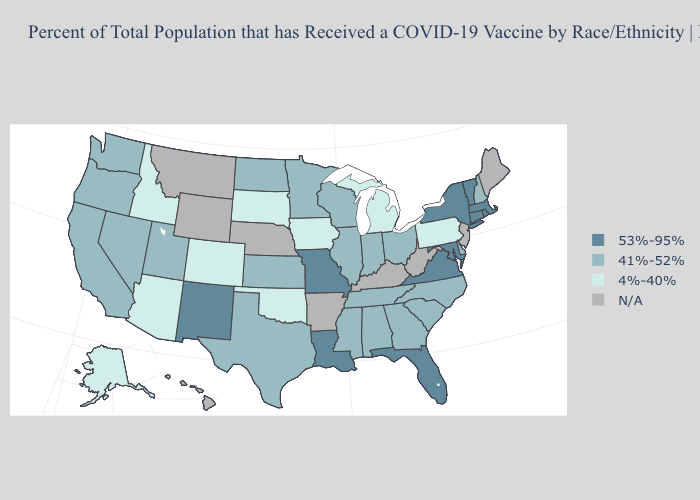Does New York have the highest value in the Northeast?
Be succinct. Yes. Does Nevada have the lowest value in the West?
Quick response, please. No. Which states have the lowest value in the MidWest?
Concise answer only. Iowa, Michigan, South Dakota. What is the value of Illinois?
Be succinct. 41%-52%. Name the states that have a value in the range 4%-40%?
Short answer required. Alaska, Arizona, Colorado, Idaho, Iowa, Michigan, Oklahoma, Pennsylvania, South Dakota. Which states have the highest value in the USA?
Give a very brief answer. Connecticut, Florida, Louisiana, Maryland, Massachusetts, Missouri, New Mexico, New York, Rhode Island, Vermont, Virginia. What is the value of New York?
Concise answer only. 53%-95%. What is the value of Arkansas?
Answer briefly. N/A. What is the value of Ohio?
Quick response, please. 41%-52%. What is the lowest value in the West?
Short answer required. 4%-40%. Name the states that have a value in the range 53%-95%?
Be succinct. Connecticut, Florida, Louisiana, Maryland, Massachusetts, Missouri, New Mexico, New York, Rhode Island, Vermont, Virginia. Is the legend a continuous bar?
Give a very brief answer. No. Name the states that have a value in the range 53%-95%?
Give a very brief answer. Connecticut, Florida, Louisiana, Maryland, Massachusetts, Missouri, New Mexico, New York, Rhode Island, Vermont, Virginia. What is the value of Nebraska?
Answer briefly. N/A. Name the states that have a value in the range N/A?
Quick response, please. Arkansas, Hawaii, Kentucky, Maine, Montana, Nebraska, New Jersey, West Virginia, Wyoming. 